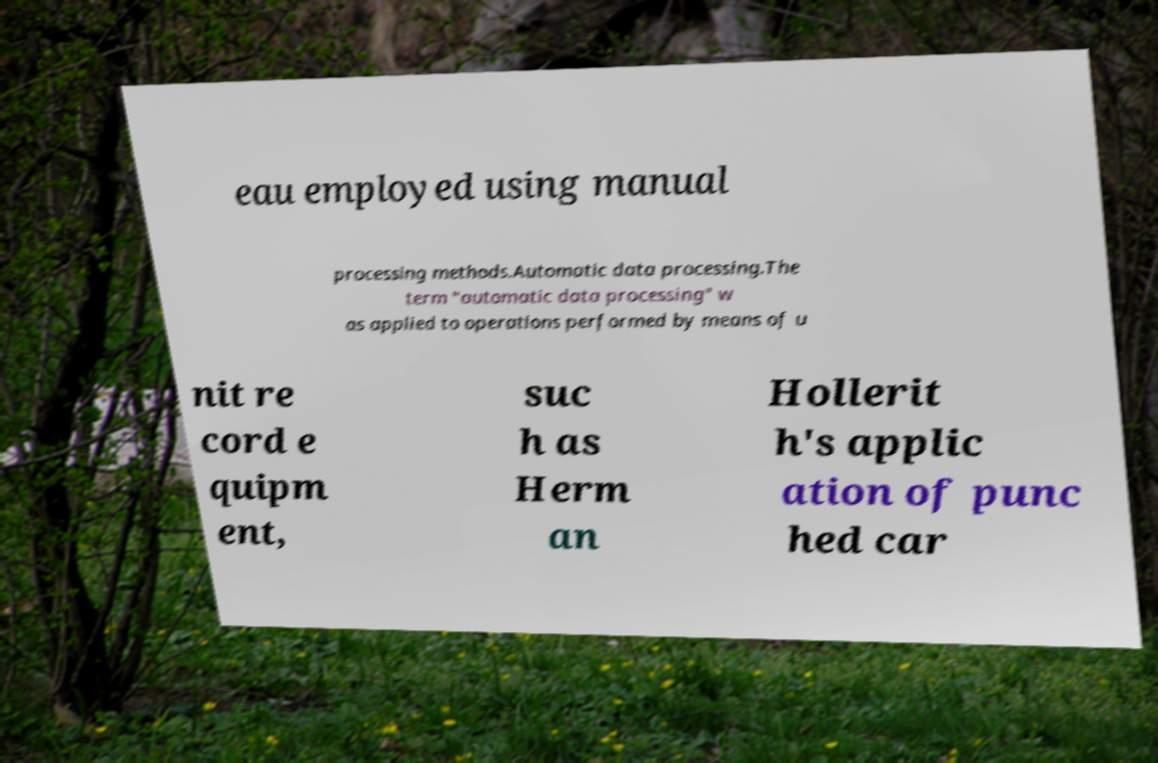Please read and relay the text visible in this image. What does it say? eau employed using manual processing methods.Automatic data processing.The term "automatic data processing" w as applied to operations performed by means of u nit re cord e quipm ent, suc h as Herm an Hollerit h's applic ation of punc hed car 